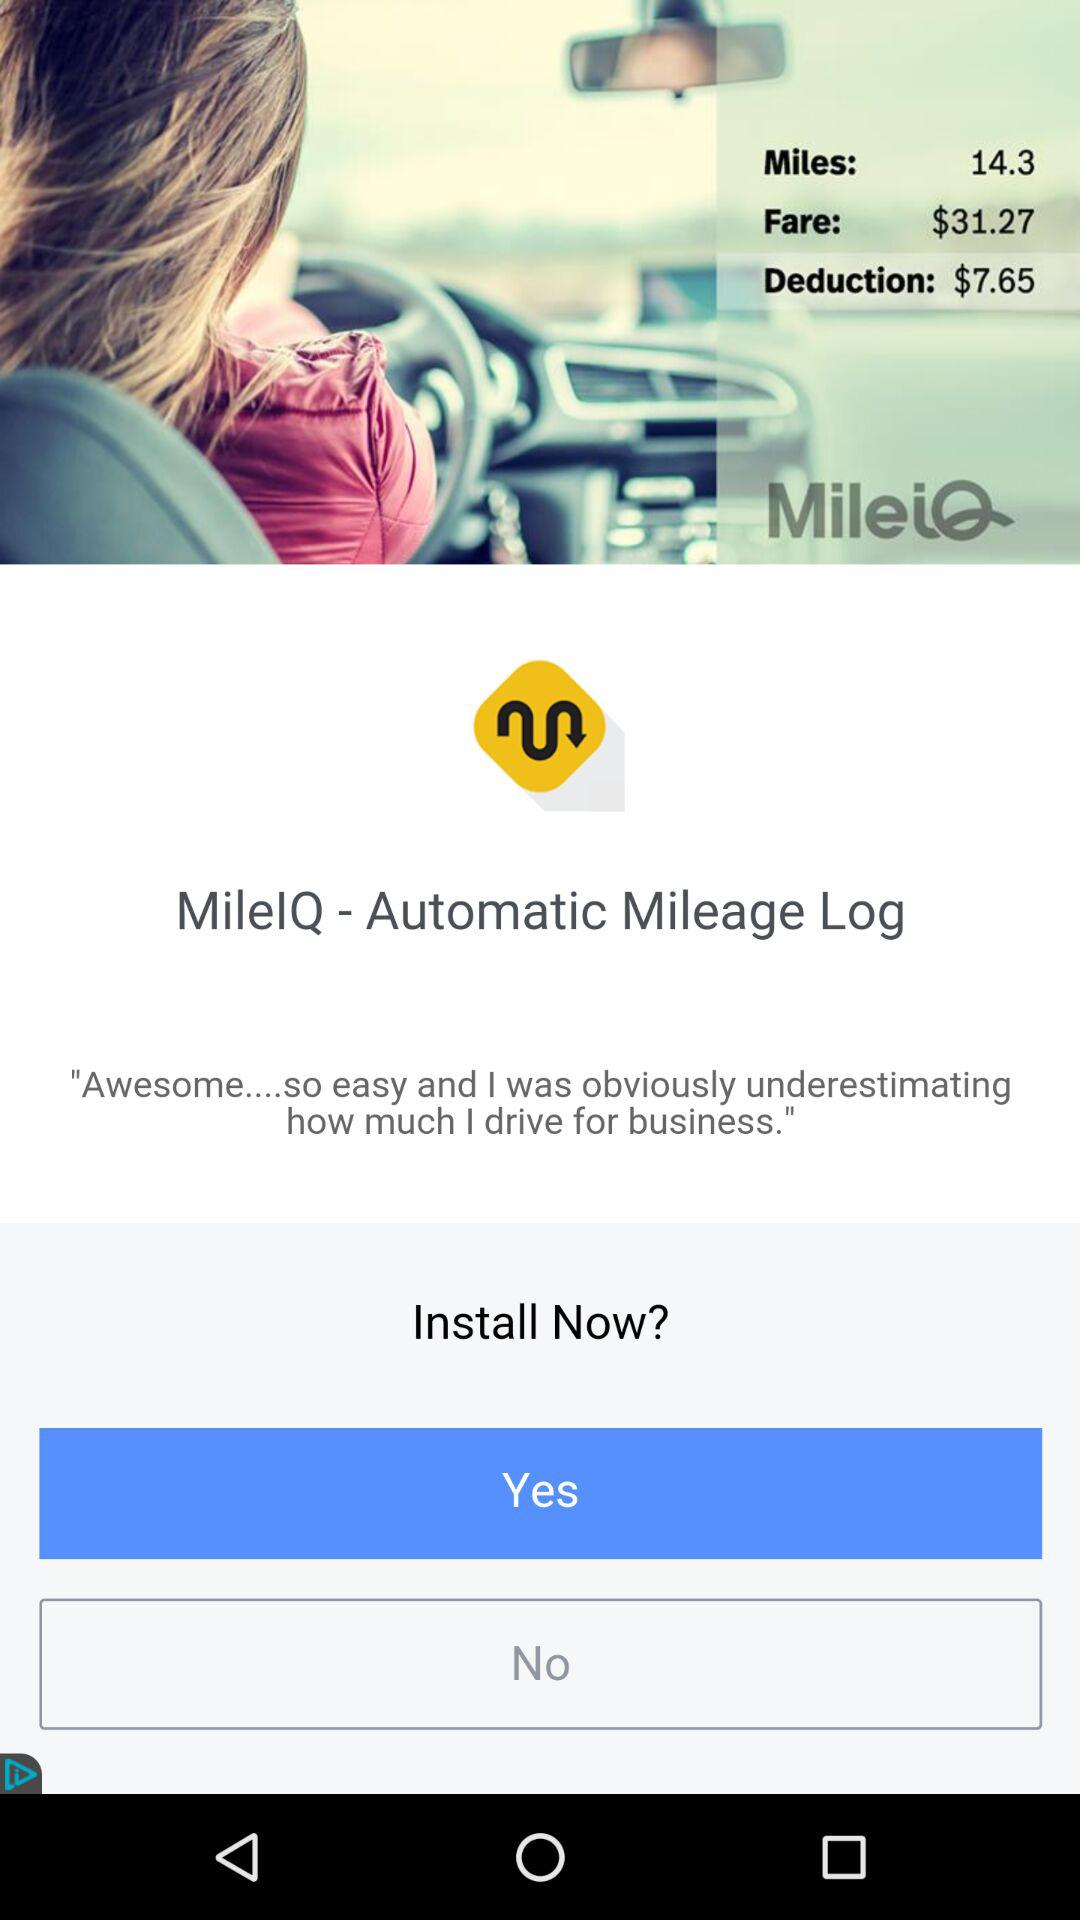How much more is the fare than the deduction?
Answer the question using a single word or phrase. $23.62 